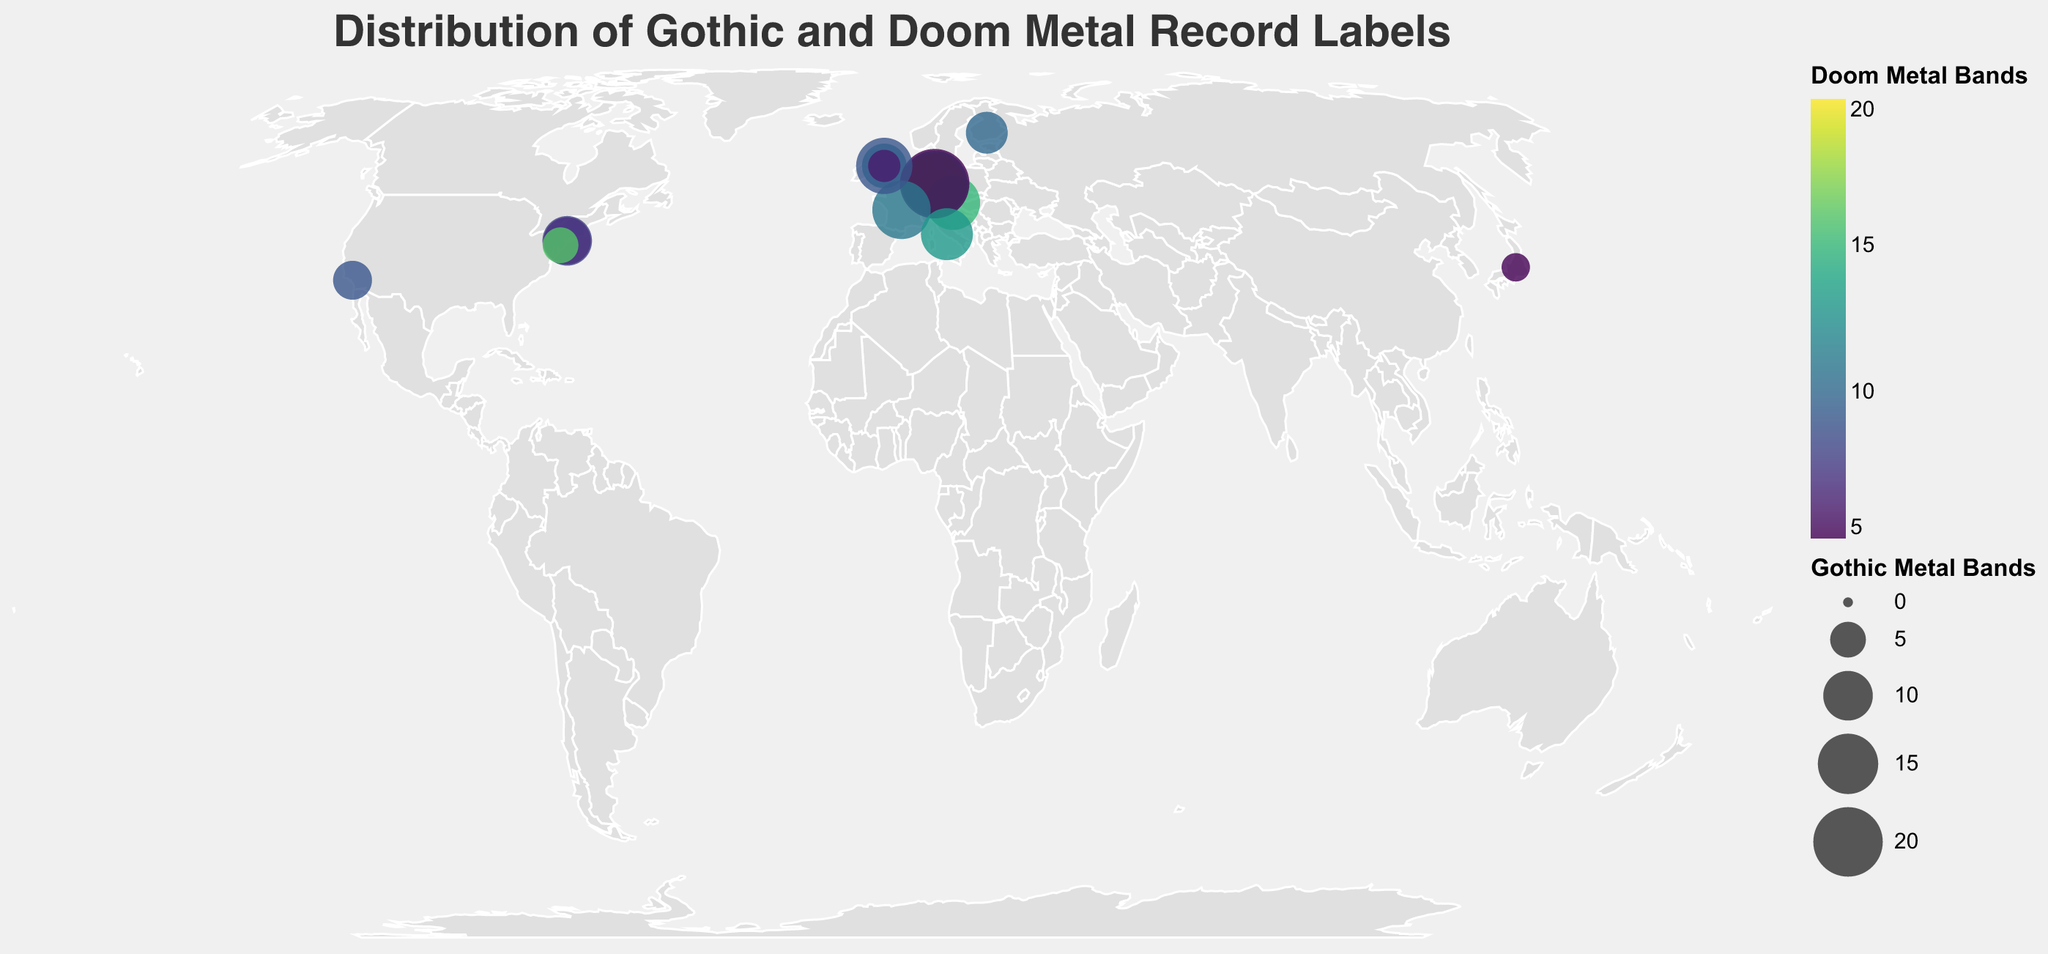What is the primary title of the plot? The primary title is usually displayed at the top of the plot in a large font size. Here, the title is "Distribution of Gothic and Doom Metal Record Labels", which is centered at the top and stands out due to its size and font.
Answer: Distribution of Gothic and Doom Metal Record Labels In which continent is the label "Roadrunner Records" located? The data points show the continent each record label is located in. By looking for "Roadrunner Records" in the plot, we find it is located in North America.
Answer: North America Which record label has the most Gothic Metal bands? By comparing the sizes of the bubbles, which represent Gothic Metal bands, the largest circle corresponds to "Prophecy Productions" in Germany with 20 Gothic Metal bands.
Answer: Prophecy Productions How many record labels in the plot are headquartered in Germany? There are multiple labels headquartered in Germany. By identifying each label and checking its headquarters, we find Nuclear Blast, Century Media, and Prophecy Productions are headquartered in Germany.
Answer: 3 Which label has a stronger focus on Doom Metal compared to Gothic Metal? By comparing both Gothic Metal and Doom Metal values for each label, we see that Relapse Records stands out with more Doom Metal bands (16) compared to Gothic Metal bands (5).
Answer: Relapse Records What is the total number of Gothic Metal bands in Europe? Sum the Gothic Metal bands for labels headquartered in Europe: Peaceville Records (8), Nuclear Blast (15), Century Media (18), Napalm Records (12), Prophecy Productions (20), Season of Mist (14), Avantgarde Music (11), Spinefarm Records (7), Candlelight Records (13), Earache Records (4). The total is 8+15+18+12+20+14+11+7+13+4.
Answer: 122 Which continent has the highest average number of Doom Metal bands per label? Calculate the average number of Doom Metal bands for each continent. For Europe: (12+20+14+15+5+11+13+10+9+6)/10 = 11.5, for North America: (8+9+7+16)/4 = 10, for Asia: 5/1 = 5. Europe has the highest average at 11.5.
Answer: Europe What is the difference in the number of Doom Metal bands between Century Media and Candlelight Records? Subtract the number of Doom Metal bands for Century Media (14) from that of Candlelight Records (9): 14 - 9 = 5.
Answer: 5 Which European record label has the least Gothic Metal bands? Look for the smallest bubble among European labels. Earache Records has the smallest with only 4 Gothic Metal bands.
Answer: Earache Records Locate the label in Asia and identify how many Doom Metal bands it has. Identifying the location in Asia and referring to the tooltip, Marquee Inc. in Japan has 5 Doom Metal bands.
Answer: 5 